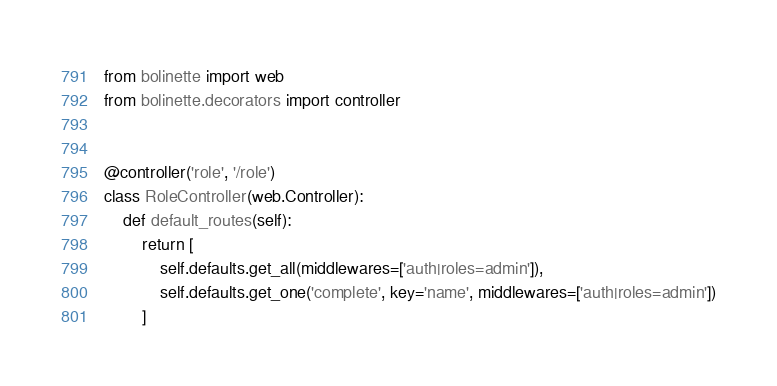Convert code to text. <code><loc_0><loc_0><loc_500><loc_500><_Python_>from bolinette import web
from bolinette.decorators import controller


@controller('role', '/role')
class RoleController(web.Controller):
    def default_routes(self):
        return [
            self.defaults.get_all(middlewares=['auth|roles=admin']),
            self.defaults.get_one('complete', key='name', middlewares=['auth|roles=admin'])
        ]
</code> 